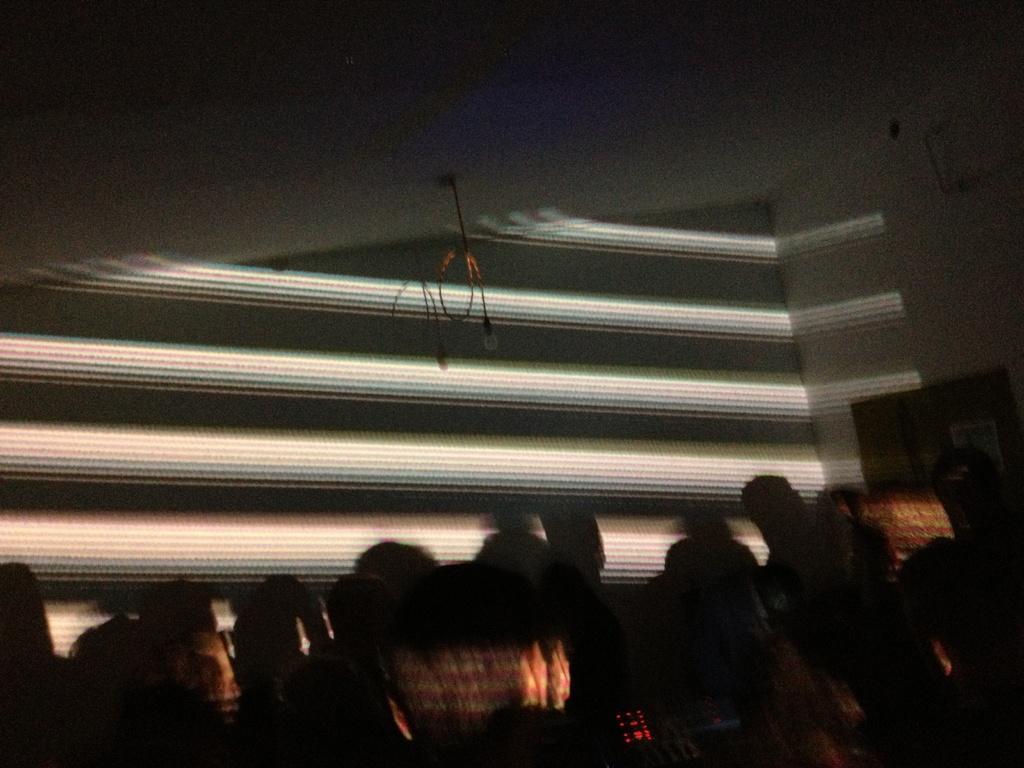Could you give a brief overview of what you see in this image? In this image, there are some people standing in a dark room. 